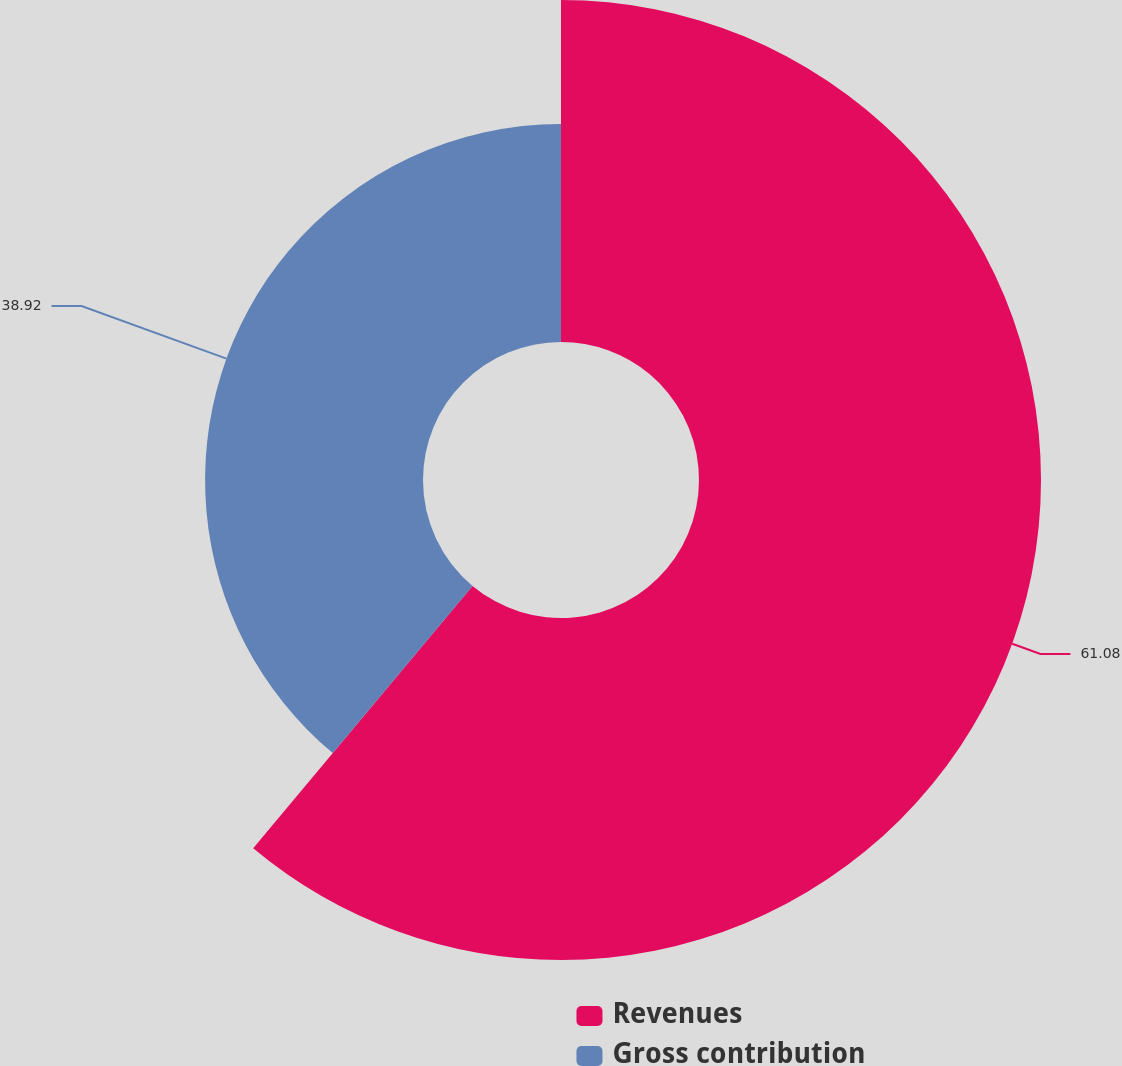<chart> <loc_0><loc_0><loc_500><loc_500><pie_chart><fcel>Revenues<fcel>Gross contribution<nl><fcel>61.08%<fcel>38.92%<nl></chart> 